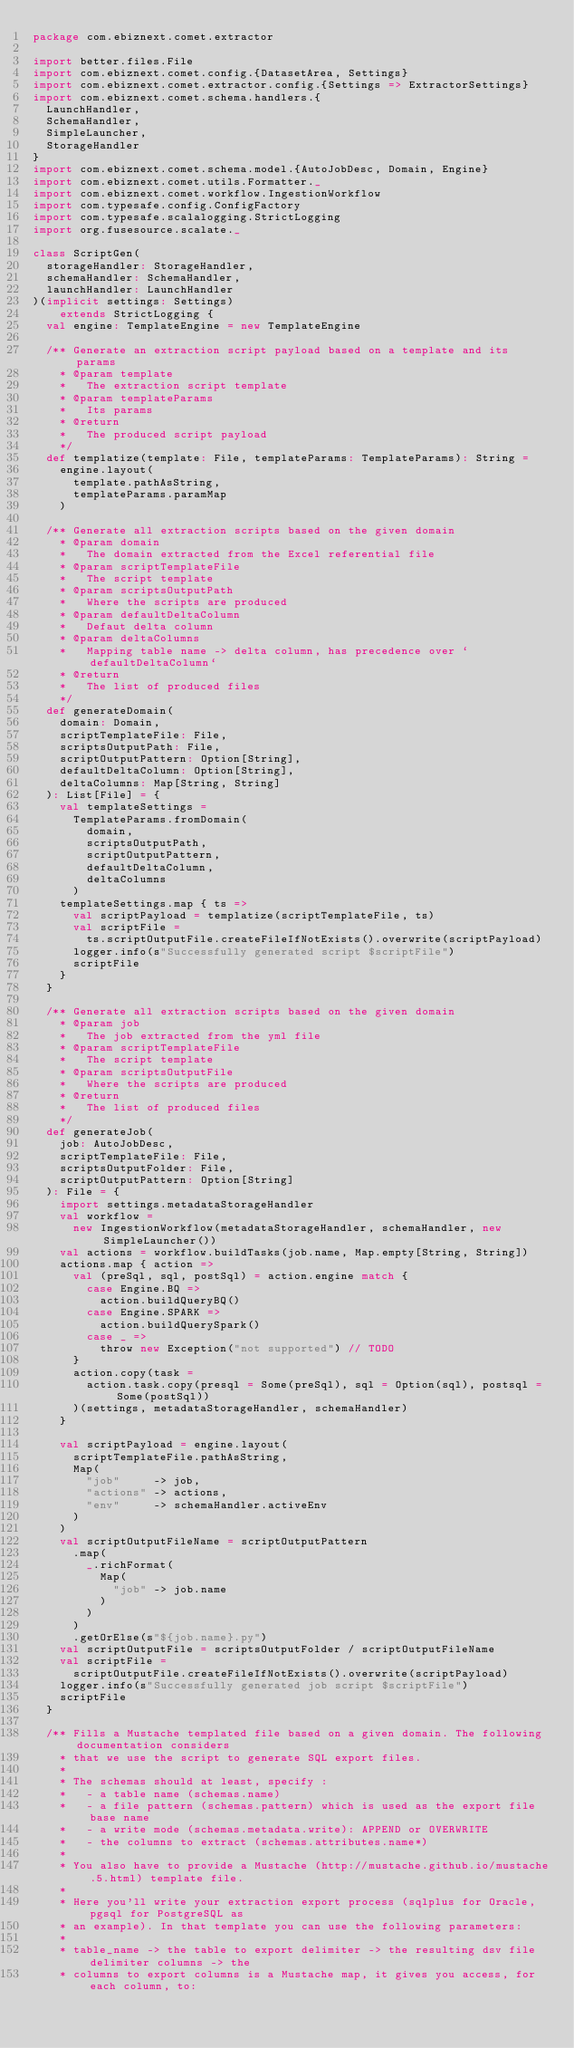Convert code to text. <code><loc_0><loc_0><loc_500><loc_500><_Scala_>package com.ebiznext.comet.extractor

import better.files.File
import com.ebiznext.comet.config.{DatasetArea, Settings}
import com.ebiznext.comet.extractor.config.{Settings => ExtractorSettings}
import com.ebiznext.comet.schema.handlers.{
  LaunchHandler,
  SchemaHandler,
  SimpleLauncher,
  StorageHandler
}
import com.ebiznext.comet.schema.model.{AutoJobDesc, Domain, Engine}
import com.ebiznext.comet.utils.Formatter._
import com.ebiznext.comet.workflow.IngestionWorkflow
import com.typesafe.config.ConfigFactory
import com.typesafe.scalalogging.StrictLogging
import org.fusesource.scalate._

class ScriptGen(
  storageHandler: StorageHandler,
  schemaHandler: SchemaHandler,
  launchHandler: LaunchHandler
)(implicit settings: Settings)
    extends StrictLogging {
  val engine: TemplateEngine = new TemplateEngine

  /** Generate an extraction script payload based on a template and its params
    * @param template
    *   The extraction script template
    * @param templateParams
    *   Its params
    * @return
    *   The produced script payload
    */
  def templatize(template: File, templateParams: TemplateParams): String =
    engine.layout(
      template.pathAsString,
      templateParams.paramMap
    )

  /** Generate all extraction scripts based on the given domain
    * @param domain
    *   The domain extracted from the Excel referential file
    * @param scriptTemplateFile
    *   The script template
    * @param scriptsOutputPath
    *   Where the scripts are produced
    * @param defaultDeltaColumn
    *   Defaut delta column
    * @param deltaColumns
    *   Mapping table name -> delta column, has precedence over `defaultDeltaColumn`
    * @return
    *   The list of produced files
    */
  def generateDomain(
    domain: Domain,
    scriptTemplateFile: File,
    scriptsOutputPath: File,
    scriptOutputPattern: Option[String],
    defaultDeltaColumn: Option[String],
    deltaColumns: Map[String, String]
  ): List[File] = {
    val templateSettings =
      TemplateParams.fromDomain(
        domain,
        scriptsOutputPath,
        scriptOutputPattern,
        defaultDeltaColumn,
        deltaColumns
      )
    templateSettings.map { ts =>
      val scriptPayload = templatize(scriptTemplateFile, ts)
      val scriptFile =
        ts.scriptOutputFile.createFileIfNotExists().overwrite(scriptPayload)
      logger.info(s"Successfully generated script $scriptFile")
      scriptFile
    }
  }

  /** Generate all extraction scripts based on the given domain
    * @param job
    *   The job extracted from the yml file
    * @param scriptTemplateFile
    *   The script template
    * @param scriptsOutputFile
    *   Where the scripts are produced
    * @return
    *   The list of produced files
    */
  def generateJob(
    job: AutoJobDesc,
    scriptTemplateFile: File,
    scriptsOutputFolder: File,
    scriptOutputPattern: Option[String]
  ): File = {
    import settings.metadataStorageHandler
    val workflow =
      new IngestionWorkflow(metadataStorageHandler, schemaHandler, new SimpleLauncher())
    val actions = workflow.buildTasks(job.name, Map.empty[String, String])
    actions.map { action =>
      val (preSql, sql, postSql) = action.engine match {
        case Engine.BQ =>
          action.buildQueryBQ()
        case Engine.SPARK =>
          action.buildQuerySpark()
        case _ =>
          throw new Exception("not supported") // TODO
      }
      action.copy(task =
        action.task.copy(presql = Some(preSql), sql = Option(sql), postsql = Some(postSql))
      )(settings, metadataStorageHandler, schemaHandler)
    }

    val scriptPayload = engine.layout(
      scriptTemplateFile.pathAsString,
      Map(
        "job"     -> job,
        "actions" -> actions,
        "env"     -> schemaHandler.activeEnv
      )
    )
    val scriptOutputFileName = scriptOutputPattern
      .map(
        _.richFormat(
          Map(
            "job" -> job.name
          )
        )
      )
      .getOrElse(s"${job.name}.py")
    val scriptOutputFile = scriptsOutputFolder / scriptOutputFileName
    val scriptFile =
      scriptOutputFile.createFileIfNotExists().overwrite(scriptPayload)
    logger.info(s"Successfully generated job script $scriptFile")
    scriptFile
  }

  /** Fills a Mustache templated file based on a given domain. The following documentation considers
    * that we use the script to generate SQL export files.
    *
    * The schemas should at least, specify :
    *   - a table name (schemas.name)
    *   - a file pattern (schemas.pattern) which is used as the export file base name
    *   - a write mode (schemas.metadata.write): APPEND or OVERWRITE
    *   - the columns to extract (schemas.attributes.name*)
    *
    * You also have to provide a Mustache (http://mustache.github.io/mustache.5.html) template file.
    *
    * Here you'll write your extraction export process (sqlplus for Oracle, pgsql for PostgreSQL as
    * an example). In that template you can use the following parameters:
    *
    * table_name -> the table to export delimiter -> the resulting dsv file delimiter columns -> the
    * columns to export columns is a Mustache map, it gives you access, for each column, to:</code> 